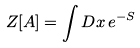Convert formula to latex. <formula><loc_0><loc_0><loc_500><loc_500>Z [ A ] = \int D x \, e ^ { - S }</formula> 